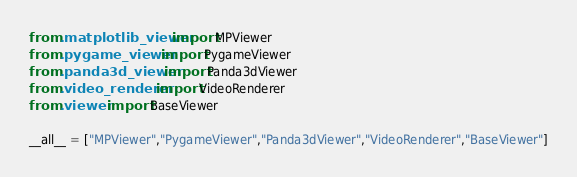Convert code to text. <code><loc_0><loc_0><loc_500><loc_500><_Python_>from .matplotlib_viewer import MPViewer
from .pygame_viewer import PygameViewer
from .panda3d_viewer import Panda3dViewer
from .video_renderer import VideoRenderer
from .viewer import BaseViewer

__all__ = ["MPViewer","PygameViewer","Panda3dViewer","VideoRenderer","BaseViewer"]
</code> 